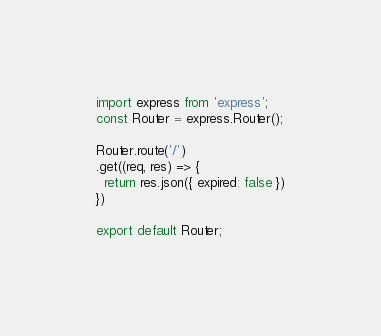Convert code to text. <code><loc_0><loc_0><loc_500><loc_500><_JavaScript_>import express from 'express';
const Router = express.Router();

Router.route('/')
.get((req, res) => {
  return res.json({ expired: false })
})

export default Router;
</code> 